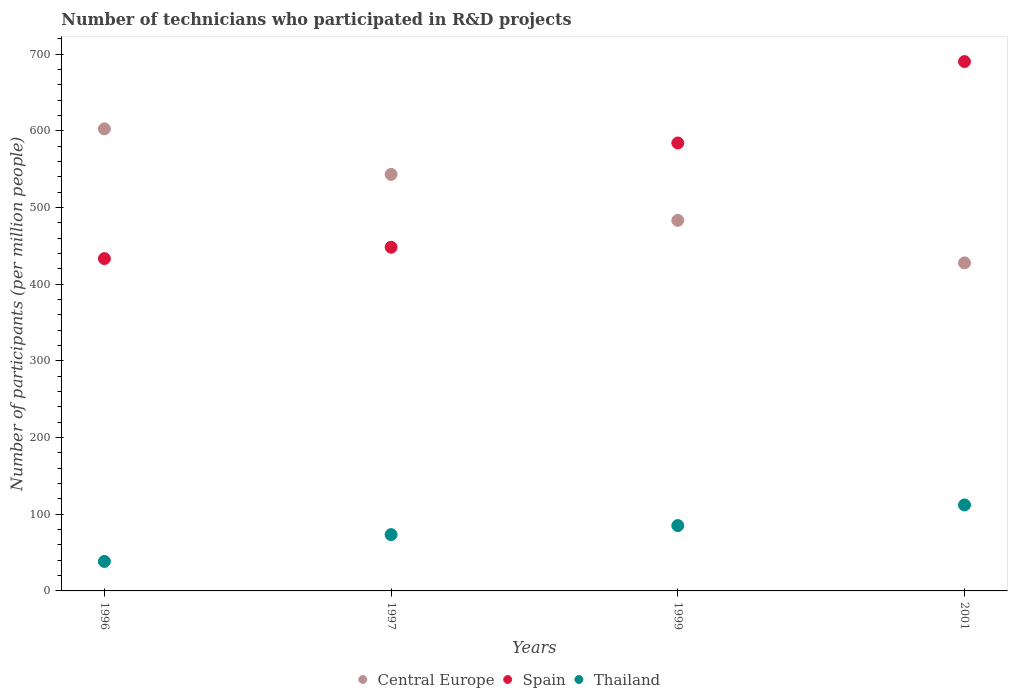Is the number of dotlines equal to the number of legend labels?
Make the answer very short. Yes. What is the number of technicians who participated in R&D projects in Spain in 1997?
Make the answer very short. 448.17. Across all years, what is the maximum number of technicians who participated in R&D projects in Spain?
Offer a very short reply. 690.27. Across all years, what is the minimum number of technicians who participated in R&D projects in Thailand?
Keep it short and to the point. 38.46. In which year was the number of technicians who participated in R&D projects in Thailand maximum?
Your answer should be compact. 2001. What is the total number of technicians who participated in R&D projects in Central Europe in the graph?
Offer a terse response. 2056.67. What is the difference between the number of technicians who participated in R&D projects in Central Europe in 1996 and that in 1997?
Offer a very short reply. 59.33. What is the difference between the number of technicians who participated in R&D projects in Thailand in 2001 and the number of technicians who participated in R&D projects in Spain in 1996?
Your answer should be compact. -321.22. What is the average number of technicians who participated in R&D projects in Thailand per year?
Provide a short and direct response. 77.31. In the year 2001, what is the difference between the number of technicians who participated in R&D projects in Thailand and number of technicians who participated in R&D projects in Central Europe?
Your answer should be compact. -315.62. What is the ratio of the number of technicians who participated in R&D projects in Thailand in 1996 to that in 2001?
Your answer should be very brief. 0.34. Is the difference between the number of technicians who participated in R&D projects in Thailand in 1996 and 1999 greater than the difference between the number of technicians who participated in R&D projects in Central Europe in 1996 and 1999?
Provide a short and direct response. No. What is the difference between the highest and the second highest number of technicians who participated in R&D projects in Spain?
Provide a short and direct response. 106.17. What is the difference between the highest and the lowest number of technicians who participated in R&D projects in Spain?
Offer a terse response. 256.93. Is the sum of the number of technicians who participated in R&D projects in Spain in 1997 and 2001 greater than the maximum number of technicians who participated in R&D projects in Thailand across all years?
Offer a very short reply. Yes. Is it the case that in every year, the sum of the number of technicians who participated in R&D projects in Thailand and number of technicians who participated in R&D projects in Spain  is greater than the number of technicians who participated in R&D projects in Central Europe?
Offer a terse response. No. Is the number of technicians who participated in R&D projects in Thailand strictly greater than the number of technicians who participated in R&D projects in Spain over the years?
Offer a terse response. No. Is the number of technicians who participated in R&D projects in Thailand strictly less than the number of technicians who participated in R&D projects in Spain over the years?
Your answer should be compact. Yes. Are the values on the major ticks of Y-axis written in scientific E-notation?
Keep it short and to the point. No. Does the graph contain any zero values?
Make the answer very short. No. How are the legend labels stacked?
Make the answer very short. Horizontal. What is the title of the graph?
Provide a succinct answer. Number of technicians who participated in R&D projects. What is the label or title of the X-axis?
Give a very brief answer. Years. What is the label or title of the Y-axis?
Offer a terse response. Number of participants (per million people). What is the Number of participants (per million people) of Central Europe in 1996?
Offer a very short reply. 602.53. What is the Number of participants (per million people) in Spain in 1996?
Your answer should be very brief. 433.34. What is the Number of participants (per million people) in Thailand in 1996?
Your answer should be compact. 38.46. What is the Number of participants (per million people) in Central Europe in 1997?
Keep it short and to the point. 543.2. What is the Number of participants (per million people) of Spain in 1997?
Ensure brevity in your answer.  448.17. What is the Number of participants (per million people) of Thailand in 1997?
Offer a terse response. 73.43. What is the Number of participants (per million people) in Central Europe in 1999?
Provide a short and direct response. 483.21. What is the Number of participants (per million people) in Spain in 1999?
Keep it short and to the point. 584.09. What is the Number of participants (per million people) of Thailand in 1999?
Give a very brief answer. 85.21. What is the Number of participants (per million people) of Central Europe in 2001?
Offer a terse response. 427.73. What is the Number of participants (per million people) in Spain in 2001?
Give a very brief answer. 690.27. What is the Number of participants (per million people) in Thailand in 2001?
Offer a terse response. 112.12. Across all years, what is the maximum Number of participants (per million people) in Central Europe?
Provide a succinct answer. 602.53. Across all years, what is the maximum Number of participants (per million people) in Spain?
Your answer should be very brief. 690.27. Across all years, what is the maximum Number of participants (per million people) of Thailand?
Give a very brief answer. 112.12. Across all years, what is the minimum Number of participants (per million people) in Central Europe?
Offer a very short reply. 427.73. Across all years, what is the minimum Number of participants (per million people) of Spain?
Provide a short and direct response. 433.34. Across all years, what is the minimum Number of participants (per million people) of Thailand?
Give a very brief answer. 38.46. What is the total Number of participants (per million people) of Central Europe in the graph?
Offer a terse response. 2056.67. What is the total Number of participants (per million people) of Spain in the graph?
Make the answer very short. 2155.86. What is the total Number of participants (per million people) in Thailand in the graph?
Ensure brevity in your answer.  309.23. What is the difference between the Number of participants (per million people) in Central Europe in 1996 and that in 1997?
Ensure brevity in your answer.  59.33. What is the difference between the Number of participants (per million people) in Spain in 1996 and that in 1997?
Your answer should be very brief. -14.83. What is the difference between the Number of participants (per million people) of Thailand in 1996 and that in 1997?
Your response must be concise. -34.97. What is the difference between the Number of participants (per million people) in Central Europe in 1996 and that in 1999?
Ensure brevity in your answer.  119.33. What is the difference between the Number of participants (per million people) of Spain in 1996 and that in 1999?
Make the answer very short. -150.76. What is the difference between the Number of participants (per million people) in Thailand in 1996 and that in 1999?
Ensure brevity in your answer.  -46.75. What is the difference between the Number of participants (per million people) in Central Europe in 1996 and that in 2001?
Make the answer very short. 174.8. What is the difference between the Number of participants (per million people) in Spain in 1996 and that in 2001?
Give a very brief answer. -256.93. What is the difference between the Number of participants (per million people) in Thailand in 1996 and that in 2001?
Keep it short and to the point. -73.66. What is the difference between the Number of participants (per million people) in Central Europe in 1997 and that in 1999?
Provide a succinct answer. 59.99. What is the difference between the Number of participants (per million people) in Spain in 1997 and that in 1999?
Make the answer very short. -135.93. What is the difference between the Number of participants (per million people) in Thailand in 1997 and that in 1999?
Your answer should be compact. -11.78. What is the difference between the Number of participants (per million people) in Central Europe in 1997 and that in 2001?
Offer a very short reply. 115.47. What is the difference between the Number of participants (per million people) in Spain in 1997 and that in 2001?
Keep it short and to the point. -242.1. What is the difference between the Number of participants (per million people) in Thailand in 1997 and that in 2001?
Provide a short and direct response. -38.69. What is the difference between the Number of participants (per million people) in Central Europe in 1999 and that in 2001?
Give a very brief answer. 55.47. What is the difference between the Number of participants (per million people) in Spain in 1999 and that in 2001?
Give a very brief answer. -106.17. What is the difference between the Number of participants (per million people) in Thailand in 1999 and that in 2001?
Provide a short and direct response. -26.91. What is the difference between the Number of participants (per million people) of Central Europe in 1996 and the Number of participants (per million people) of Spain in 1997?
Offer a terse response. 154.37. What is the difference between the Number of participants (per million people) in Central Europe in 1996 and the Number of participants (per million people) in Thailand in 1997?
Make the answer very short. 529.1. What is the difference between the Number of participants (per million people) of Spain in 1996 and the Number of participants (per million people) of Thailand in 1997?
Your answer should be compact. 359.9. What is the difference between the Number of participants (per million people) of Central Europe in 1996 and the Number of participants (per million people) of Spain in 1999?
Your response must be concise. 18.44. What is the difference between the Number of participants (per million people) in Central Europe in 1996 and the Number of participants (per million people) in Thailand in 1999?
Offer a very short reply. 517.32. What is the difference between the Number of participants (per million people) of Spain in 1996 and the Number of participants (per million people) of Thailand in 1999?
Your answer should be compact. 348.12. What is the difference between the Number of participants (per million people) in Central Europe in 1996 and the Number of participants (per million people) in Spain in 2001?
Offer a terse response. -87.73. What is the difference between the Number of participants (per million people) in Central Europe in 1996 and the Number of participants (per million people) in Thailand in 2001?
Give a very brief answer. 490.41. What is the difference between the Number of participants (per million people) in Spain in 1996 and the Number of participants (per million people) in Thailand in 2001?
Offer a very short reply. 321.22. What is the difference between the Number of participants (per million people) of Central Europe in 1997 and the Number of participants (per million people) of Spain in 1999?
Your answer should be compact. -40.89. What is the difference between the Number of participants (per million people) of Central Europe in 1997 and the Number of participants (per million people) of Thailand in 1999?
Keep it short and to the point. 457.99. What is the difference between the Number of participants (per million people) of Spain in 1997 and the Number of participants (per million people) of Thailand in 1999?
Ensure brevity in your answer.  362.95. What is the difference between the Number of participants (per million people) in Central Europe in 1997 and the Number of participants (per million people) in Spain in 2001?
Make the answer very short. -147.07. What is the difference between the Number of participants (per million people) in Central Europe in 1997 and the Number of participants (per million people) in Thailand in 2001?
Give a very brief answer. 431.08. What is the difference between the Number of participants (per million people) of Spain in 1997 and the Number of participants (per million people) of Thailand in 2001?
Make the answer very short. 336.05. What is the difference between the Number of participants (per million people) in Central Europe in 1999 and the Number of participants (per million people) in Spain in 2001?
Provide a succinct answer. -207.06. What is the difference between the Number of participants (per million people) of Central Europe in 1999 and the Number of participants (per million people) of Thailand in 2001?
Your answer should be compact. 371.09. What is the difference between the Number of participants (per million people) of Spain in 1999 and the Number of participants (per million people) of Thailand in 2001?
Ensure brevity in your answer.  471.97. What is the average Number of participants (per million people) of Central Europe per year?
Ensure brevity in your answer.  514.17. What is the average Number of participants (per million people) of Spain per year?
Offer a terse response. 538.97. What is the average Number of participants (per million people) in Thailand per year?
Keep it short and to the point. 77.31. In the year 1996, what is the difference between the Number of participants (per million people) of Central Europe and Number of participants (per million people) of Spain?
Keep it short and to the point. 169.2. In the year 1996, what is the difference between the Number of participants (per million people) of Central Europe and Number of participants (per million people) of Thailand?
Ensure brevity in your answer.  564.07. In the year 1996, what is the difference between the Number of participants (per million people) in Spain and Number of participants (per million people) in Thailand?
Make the answer very short. 394.88. In the year 1997, what is the difference between the Number of participants (per million people) of Central Europe and Number of participants (per million people) of Spain?
Your answer should be compact. 95.03. In the year 1997, what is the difference between the Number of participants (per million people) of Central Europe and Number of participants (per million people) of Thailand?
Provide a short and direct response. 469.77. In the year 1997, what is the difference between the Number of participants (per million people) of Spain and Number of participants (per million people) of Thailand?
Keep it short and to the point. 374.73. In the year 1999, what is the difference between the Number of participants (per million people) in Central Europe and Number of participants (per million people) in Spain?
Your answer should be very brief. -100.89. In the year 1999, what is the difference between the Number of participants (per million people) of Central Europe and Number of participants (per million people) of Thailand?
Your answer should be very brief. 397.99. In the year 1999, what is the difference between the Number of participants (per million people) of Spain and Number of participants (per million people) of Thailand?
Provide a short and direct response. 498.88. In the year 2001, what is the difference between the Number of participants (per million people) in Central Europe and Number of participants (per million people) in Spain?
Provide a succinct answer. -262.53. In the year 2001, what is the difference between the Number of participants (per million people) of Central Europe and Number of participants (per million people) of Thailand?
Make the answer very short. 315.62. In the year 2001, what is the difference between the Number of participants (per million people) in Spain and Number of participants (per million people) in Thailand?
Make the answer very short. 578.15. What is the ratio of the Number of participants (per million people) of Central Europe in 1996 to that in 1997?
Your answer should be very brief. 1.11. What is the ratio of the Number of participants (per million people) in Spain in 1996 to that in 1997?
Offer a very short reply. 0.97. What is the ratio of the Number of participants (per million people) of Thailand in 1996 to that in 1997?
Your answer should be compact. 0.52. What is the ratio of the Number of participants (per million people) in Central Europe in 1996 to that in 1999?
Your answer should be very brief. 1.25. What is the ratio of the Number of participants (per million people) of Spain in 1996 to that in 1999?
Offer a terse response. 0.74. What is the ratio of the Number of participants (per million people) in Thailand in 1996 to that in 1999?
Your answer should be very brief. 0.45. What is the ratio of the Number of participants (per million people) in Central Europe in 1996 to that in 2001?
Give a very brief answer. 1.41. What is the ratio of the Number of participants (per million people) in Spain in 1996 to that in 2001?
Your answer should be very brief. 0.63. What is the ratio of the Number of participants (per million people) in Thailand in 1996 to that in 2001?
Offer a terse response. 0.34. What is the ratio of the Number of participants (per million people) of Central Europe in 1997 to that in 1999?
Your answer should be very brief. 1.12. What is the ratio of the Number of participants (per million people) of Spain in 1997 to that in 1999?
Keep it short and to the point. 0.77. What is the ratio of the Number of participants (per million people) of Thailand in 1997 to that in 1999?
Offer a very short reply. 0.86. What is the ratio of the Number of participants (per million people) in Central Europe in 1997 to that in 2001?
Offer a terse response. 1.27. What is the ratio of the Number of participants (per million people) in Spain in 1997 to that in 2001?
Give a very brief answer. 0.65. What is the ratio of the Number of participants (per million people) in Thailand in 1997 to that in 2001?
Provide a short and direct response. 0.66. What is the ratio of the Number of participants (per million people) of Central Europe in 1999 to that in 2001?
Your response must be concise. 1.13. What is the ratio of the Number of participants (per million people) in Spain in 1999 to that in 2001?
Offer a terse response. 0.85. What is the ratio of the Number of participants (per million people) of Thailand in 1999 to that in 2001?
Keep it short and to the point. 0.76. What is the difference between the highest and the second highest Number of participants (per million people) in Central Europe?
Ensure brevity in your answer.  59.33. What is the difference between the highest and the second highest Number of participants (per million people) of Spain?
Provide a short and direct response. 106.17. What is the difference between the highest and the second highest Number of participants (per million people) in Thailand?
Give a very brief answer. 26.91. What is the difference between the highest and the lowest Number of participants (per million people) of Central Europe?
Your answer should be compact. 174.8. What is the difference between the highest and the lowest Number of participants (per million people) in Spain?
Make the answer very short. 256.93. What is the difference between the highest and the lowest Number of participants (per million people) in Thailand?
Ensure brevity in your answer.  73.66. 